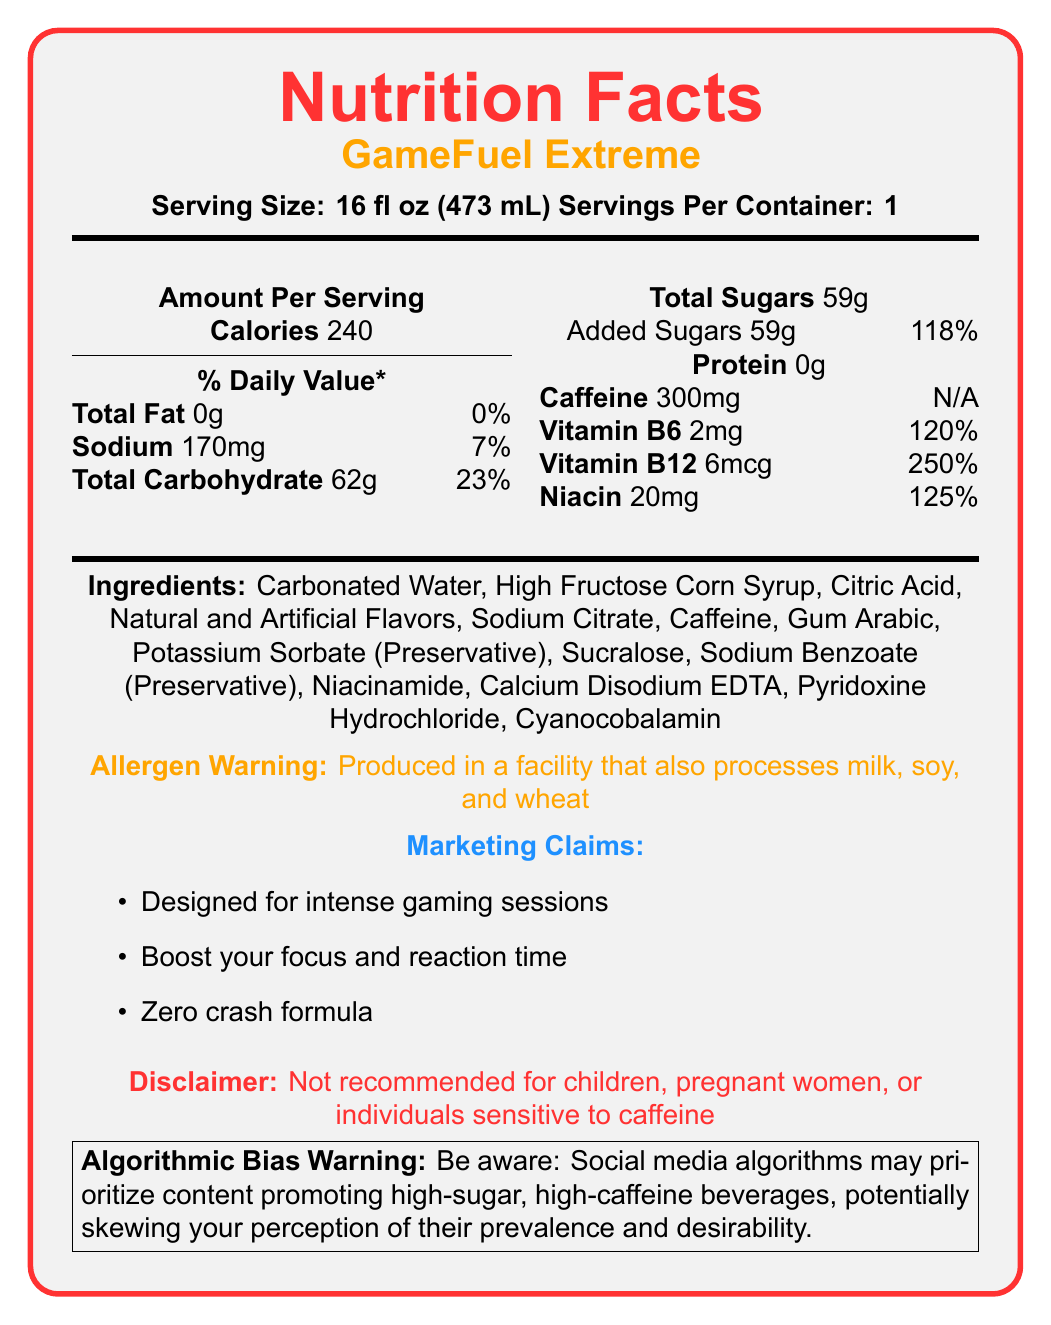What is the serving size of GameFuel Extreme? The serving size is specified near the top of the Nutrition Facts where it says "Serving Size: 16 fl oz (473 mL)".
Answer: 16 fl oz (473 mL) How many calories are in one serving of GameFuel Extreme? The amount of calories per serving is listed under "Amount Per Serving" as 240.
Answer: 240 What is the amount of caffeine in one serving of GameFuel Extreme? The caffeine content is listed under the nutritional information as "Caffeine 300mg".
Answer: 300mg How much of the daily value of sodium does one serving of GameFuel Extreme provide? The sodium daily value percentage is listed along with the sodium content as "Sodium 170mg 7%".
Answer: 7% What are the marketing claims of GameFuel Extreme? The marketing claims are listed under the "Marketing Claims" section in the document.
Answer: Designed for intense gaming sessions, Boost your focus and reaction time, Zero crash formula How much total sugars are in one serving? The total sugars content is listed under the nutritional information as "Total Sugars 59g".
Answer: 59g What vitamins are present in GameFuel Extreme? A. Vitamin C B. Vitamin B6 C. Vitamin D D. Folate The document lists Vitamin B6, Vitamin B12, and Niacin as the available vitamins, and Vitamin B6 is one of the options.
Answer: B. Vitamin B6 What percentage of the daily value of added sugars does GameFuel Extreme contain? A. 50% B. 100% C. 118% The added sugars daily value percentage is listed as "Added Sugars 59g 118%".
Answer: C. 118% Is GameFuel Extreme recommended for children? The disclaimer at the bottom clearly states that it is "Not recommended for children".
Answer: No Summarize the key information provided in the GameFuel Extreme Nutrition Facts document. The document provides details about the nutritional content, serving size, ingredients, and marketing claims about the energy drink. It highlights high caffeine and sugar content, and includes warnings related to allergens and high caffeine sensitivity.
Answer: The GameFuel Extreme nutrition facts document details that the energy drink is aimed at gamers and contains high caffeine (300mg) and sugar (59g) content. It has 240 calories per serving and includes various vitamins like B6, B12, and Niacin. It also carries an allergen warning and disclaimer about who should not consume it. How much protein is in one serving of GameFuel Extreme? The protein content is listed under the nutritional information as "Protein 0g".
Answer: 0g List two preservatives found in GameFuel Extreme. The ingredient list includes Potassium Sorbate and Sodium Benzoate as preservatives.
Answer: Potassium Sorbate, Sodium Benzoate What is the main ingredient in GameFuel Extreme? The first ingredient listed is Carbonated Water.
Answer: Carbonated Water From what you can see, does GameFuel Extreme contain any artificial flavors? The ingredients list includes "Natural and Artificial Flavors".
Answer: Yes What is the daily value percentage for Niacin in GameFuel Extreme? The document lists Niacin as providing 125% of the daily value.
Answer: 125% What is the warning about algorithmic bias mentioned in the document? The document includes a special warning about how social media algorithms can influence perception by prioritizing certain content, including high-sugar, high-caffeine beverages.
Answer: Be aware: Social media algorithms may prioritize content promoting high-sugar, high-caffeine beverages, potentially skewing your perception of their prevalence and desirability. Can the exact energy boost from consuming GameFuel Extreme be determined from the document? The document provides the nutritional content and marketing claims but does not quantify the exact energy or performance boost from consuming the drink.
Answer: Not enough information 